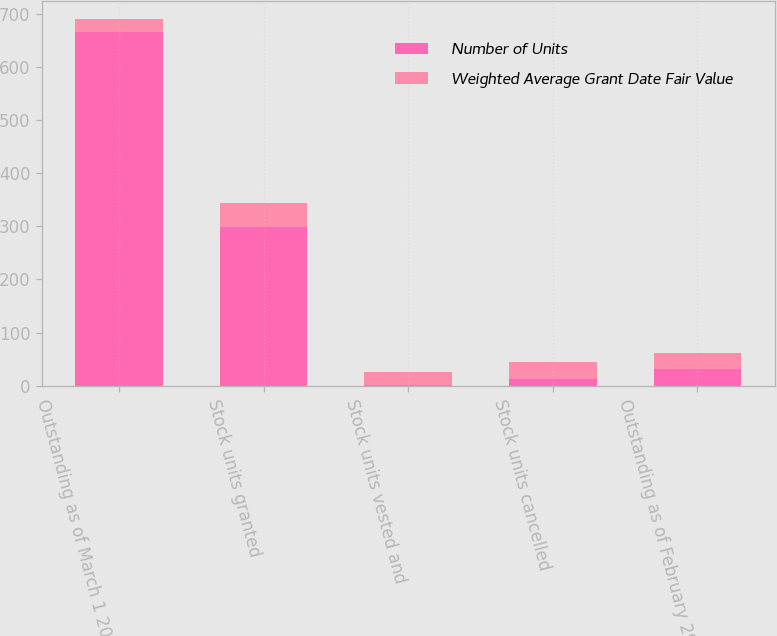Convert chart. <chart><loc_0><loc_0><loc_500><loc_500><stacked_bar_chart><ecel><fcel>Outstanding as of March 1 2011<fcel>Stock units granted<fcel>Stock units vested and<fcel>Stock units cancelled<fcel>Outstanding as of February 29<nl><fcel>Number of Units<fcel>666<fcel>299<fcel>2<fcel>13<fcel>31.02<nl><fcel>Weighted Average Grant Date Fair Value<fcel>24.66<fcel>45.48<fcel>24.19<fcel>31.02<fcel>31.12<nl></chart> 